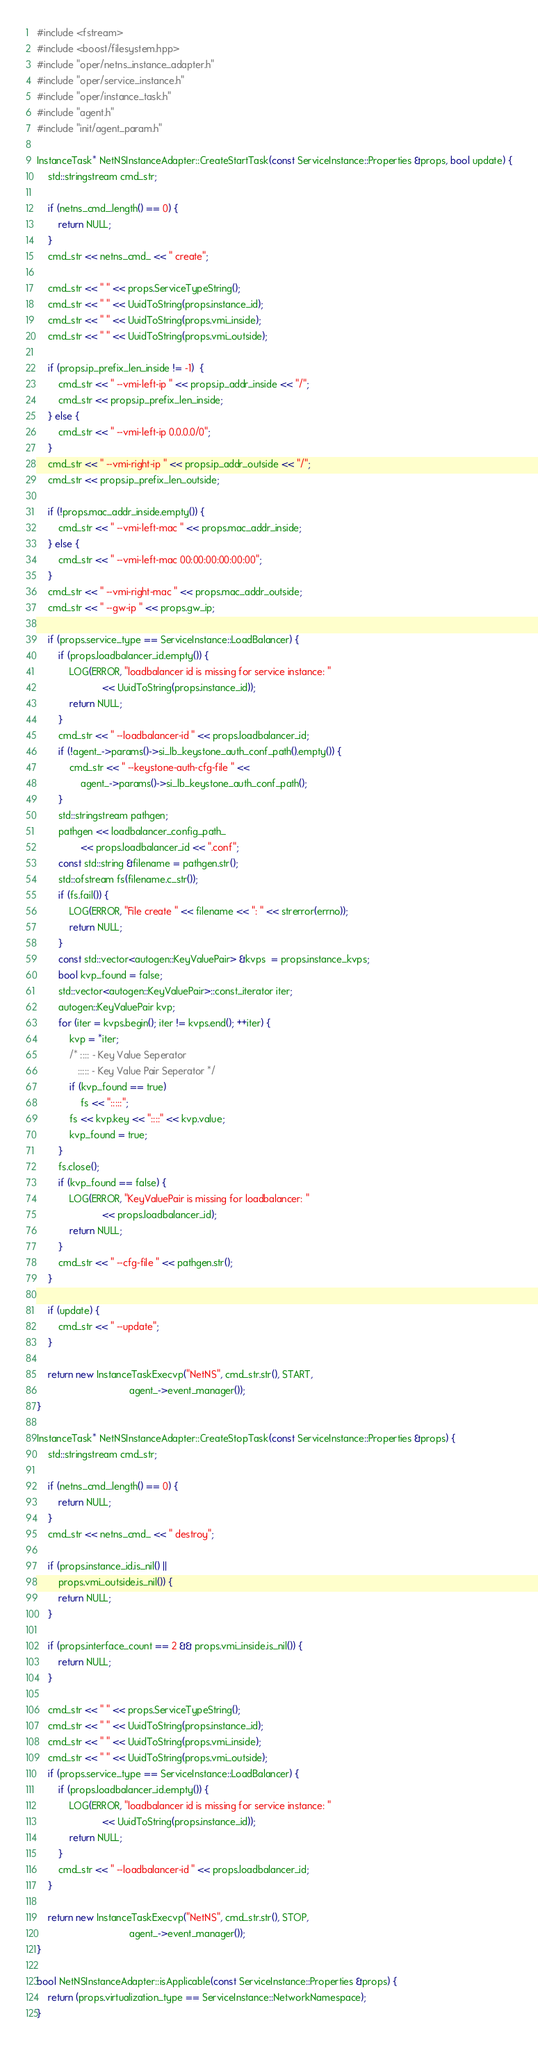Convert code to text. <code><loc_0><loc_0><loc_500><loc_500><_C++_>#include <fstream>
#include <boost/filesystem.hpp>
#include "oper/netns_instance_adapter.h"
#include "oper/service_instance.h"
#include "oper/instance_task.h"
#include "agent.h"
#include "init/agent_param.h"

InstanceTask* NetNSInstanceAdapter::CreateStartTask(const ServiceInstance::Properties &props, bool update) {
    std::stringstream cmd_str;

    if (netns_cmd_.length() == 0) {
        return NULL;
    }
    cmd_str << netns_cmd_ << " create";

    cmd_str << " " << props.ServiceTypeString();
    cmd_str << " " << UuidToString(props.instance_id);
    cmd_str << " " << UuidToString(props.vmi_inside);
    cmd_str << " " << UuidToString(props.vmi_outside);

    if (props.ip_prefix_len_inside != -1)  {
        cmd_str << " --vmi-left-ip " << props.ip_addr_inside << "/";
        cmd_str << props.ip_prefix_len_inside;
    } else {
        cmd_str << " --vmi-left-ip 0.0.0.0/0";
    }
    cmd_str << " --vmi-right-ip " << props.ip_addr_outside << "/";
    cmd_str << props.ip_prefix_len_outside;

    if (!props.mac_addr_inside.empty()) {
        cmd_str << " --vmi-left-mac " << props.mac_addr_inside;
    } else {
        cmd_str << " --vmi-left-mac 00:00:00:00:00:00";
    }
    cmd_str << " --vmi-right-mac " << props.mac_addr_outside;
    cmd_str << " --gw-ip " << props.gw_ip;

    if (props.service_type == ServiceInstance::LoadBalancer) {
        if (props.loadbalancer_id.empty()) {
            LOG(ERROR, "loadbalancer id is missing for service instance: "
                        << UuidToString(props.instance_id));
            return NULL;
        }
        cmd_str << " --loadbalancer-id " << props.loadbalancer_id;
        if (!agent_->params()->si_lb_keystone_auth_conf_path().empty()) {
            cmd_str << " --keystone-auth-cfg-file " <<
                agent_->params()->si_lb_keystone_auth_conf_path();
        }
        std::stringstream pathgen;
        pathgen << loadbalancer_config_path_
                << props.loadbalancer_id << ".conf";
        const std::string &filename = pathgen.str();
        std::ofstream fs(filename.c_str());
        if (fs.fail()) {
            LOG(ERROR, "File create " << filename << ": " << strerror(errno));
            return NULL;
        }
        const std::vector<autogen::KeyValuePair> &kvps  = props.instance_kvps;
        bool kvp_found = false;
        std::vector<autogen::KeyValuePair>::const_iterator iter;
        autogen::KeyValuePair kvp;
        for (iter = kvps.begin(); iter != kvps.end(); ++iter) {
            kvp = *iter;
            /* :::: - Key Value Seperator
               ::::: - Key Value Pair Seperator */
            if (kvp_found == true)
                fs << ":::::";
            fs << kvp.key << "::::" << kvp.value;
            kvp_found = true;
        }
        fs.close();
        if (kvp_found == false) {
            LOG(ERROR, "KeyValuePair is missing for loadbalancer: "
                        << props.loadbalancer_id);
            return NULL;
        }
        cmd_str << " --cfg-file " << pathgen.str();
    }

    if (update) {
        cmd_str << " --update";
    }

    return new InstanceTaskExecvp("NetNS", cmd_str.str(), START,
                                  agent_->event_manager());
}

InstanceTask* NetNSInstanceAdapter::CreateStopTask(const ServiceInstance::Properties &props) {
    std::stringstream cmd_str;

    if (netns_cmd_.length() == 0) {
        return NULL;
    }
    cmd_str << netns_cmd_ << " destroy";

    if (props.instance_id.is_nil() ||
        props.vmi_outside.is_nil()) {
        return NULL;
    }

    if (props.interface_count == 2 && props.vmi_inside.is_nil()) {
        return NULL;
    }

    cmd_str << " " << props.ServiceTypeString();
    cmd_str << " " << UuidToString(props.instance_id);
    cmd_str << " " << UuidToString(props.vmi_inside);
    cmd_str << " " << UuidToString(props.vmi_outside);
    if (props.service_type == ServiceInstance::LoadBalancer) {
        if (props.loadbalancer_id.empty()) {
            LOG(ERROR, "loadbalancer id is missing for service instance: "
                        << UuidToString(props.instance_id));
            return NULL;
        }
        cmd_str << " --loadbalancer-id " << props.loadbalancer_id;
    }

    return new InstanceTaskExecvp("NetNS", cmd_str.str(), STOP,
                                  agent_->event_manager());
}

bool NetNSInstanceAdapter::isApplicable(const ServiceInstance::Properties &props) {
    return (props.virtualization_type == ServiceInstance::NetworkNamespace);
}
</code> 